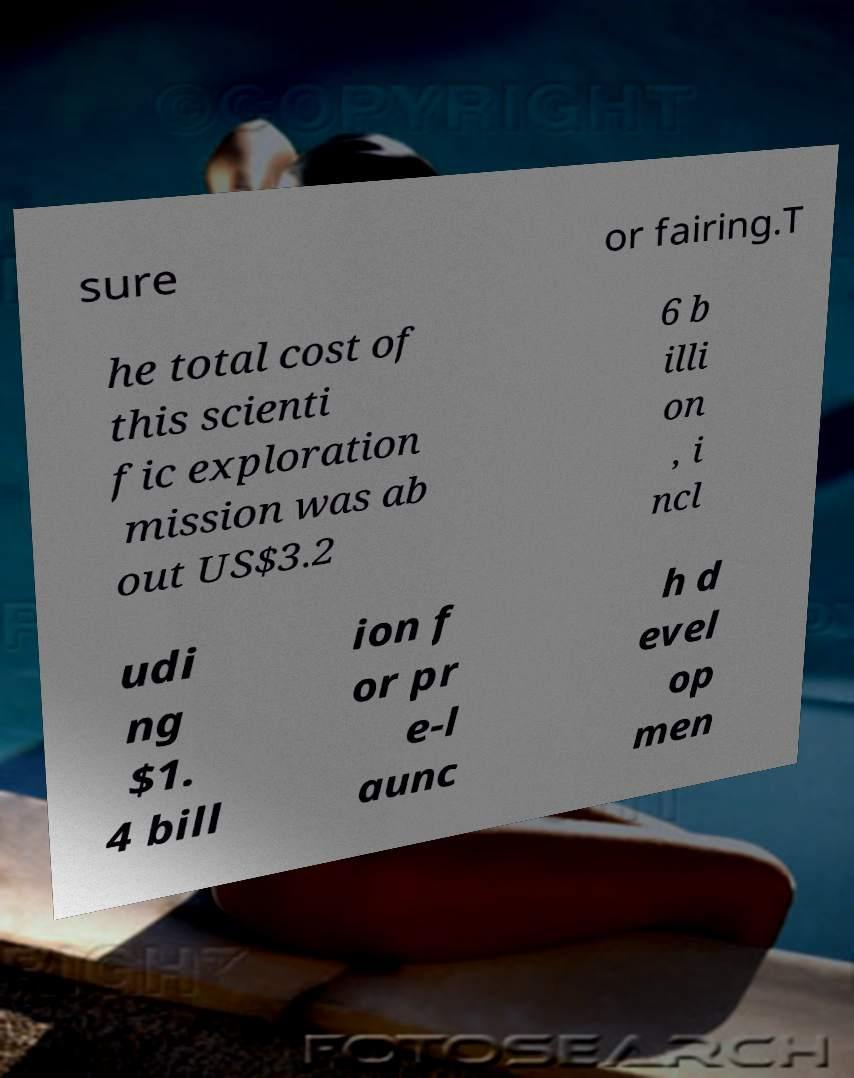Could you extract and type out the text from this image? sure or fairing.T he total cost of this scienti fic exploration mission was ab out US$3.2 6 b illi on , i ncl udi ng $1. 4 bill ion f or pr e-l aunc h d evel op men 